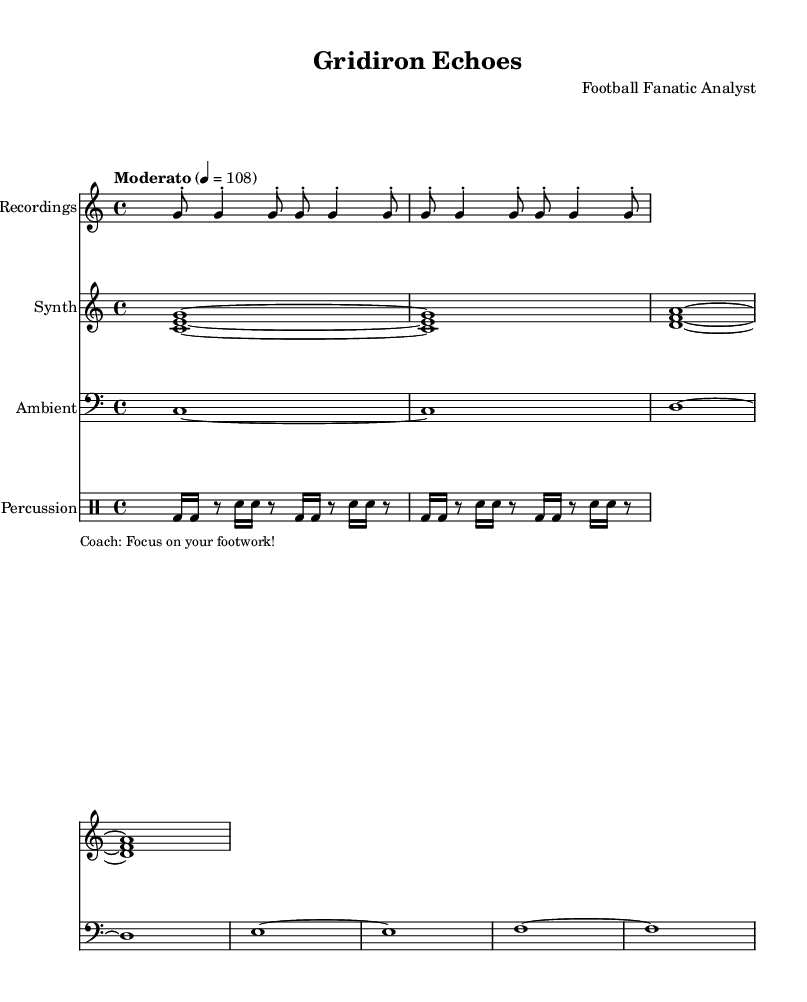What is the time signature of this music? The time signature appears at the start of the piece, indicated by "4/4" at the beginning. This means there are four beats in each measure, and the quarter note gets one beat.
Answer: 4/4 What is the tempo marking for this composition? The tempo marking is shown in the global section, and it is written as "Moderato" with a metronome marking of 108, indicating a moderate speed of play.
Answer: Moderato 4 = 108 What instruments are used in this score? The score contains three staves labeled: "Field Recordings," "Synth," and "Ambient," along with a DrumStaff labeled "Percussion." Each staff represents a different sound source or instrumental part.
Answer: Field Recordings, Synth, Ambient, Percussion How many times is the whistle pattern repeated? The whistle pattern, labeled "whistleBlows," is noted to repeat 4 times as indicated by the "repeat unfold 4" directive.
Answer: 4 What types of sounds are present in the locker room section? The locker room section is notated in the bass clef and consists of sustained pitches that appear to evoke an ambient atmosphere, specifically continuous whole notes on C, D, E, and F.
Answer: C, D, E, F How is the percussion section structured in terms of sounds? The percussion section features a repeating rhythm pattern detailed in the drummode, consisting of bass drum and snare drum hits in a pattern of sixteenth notes and rests, creating a dynamic rhythm.
Answer: Bass drum, snare 